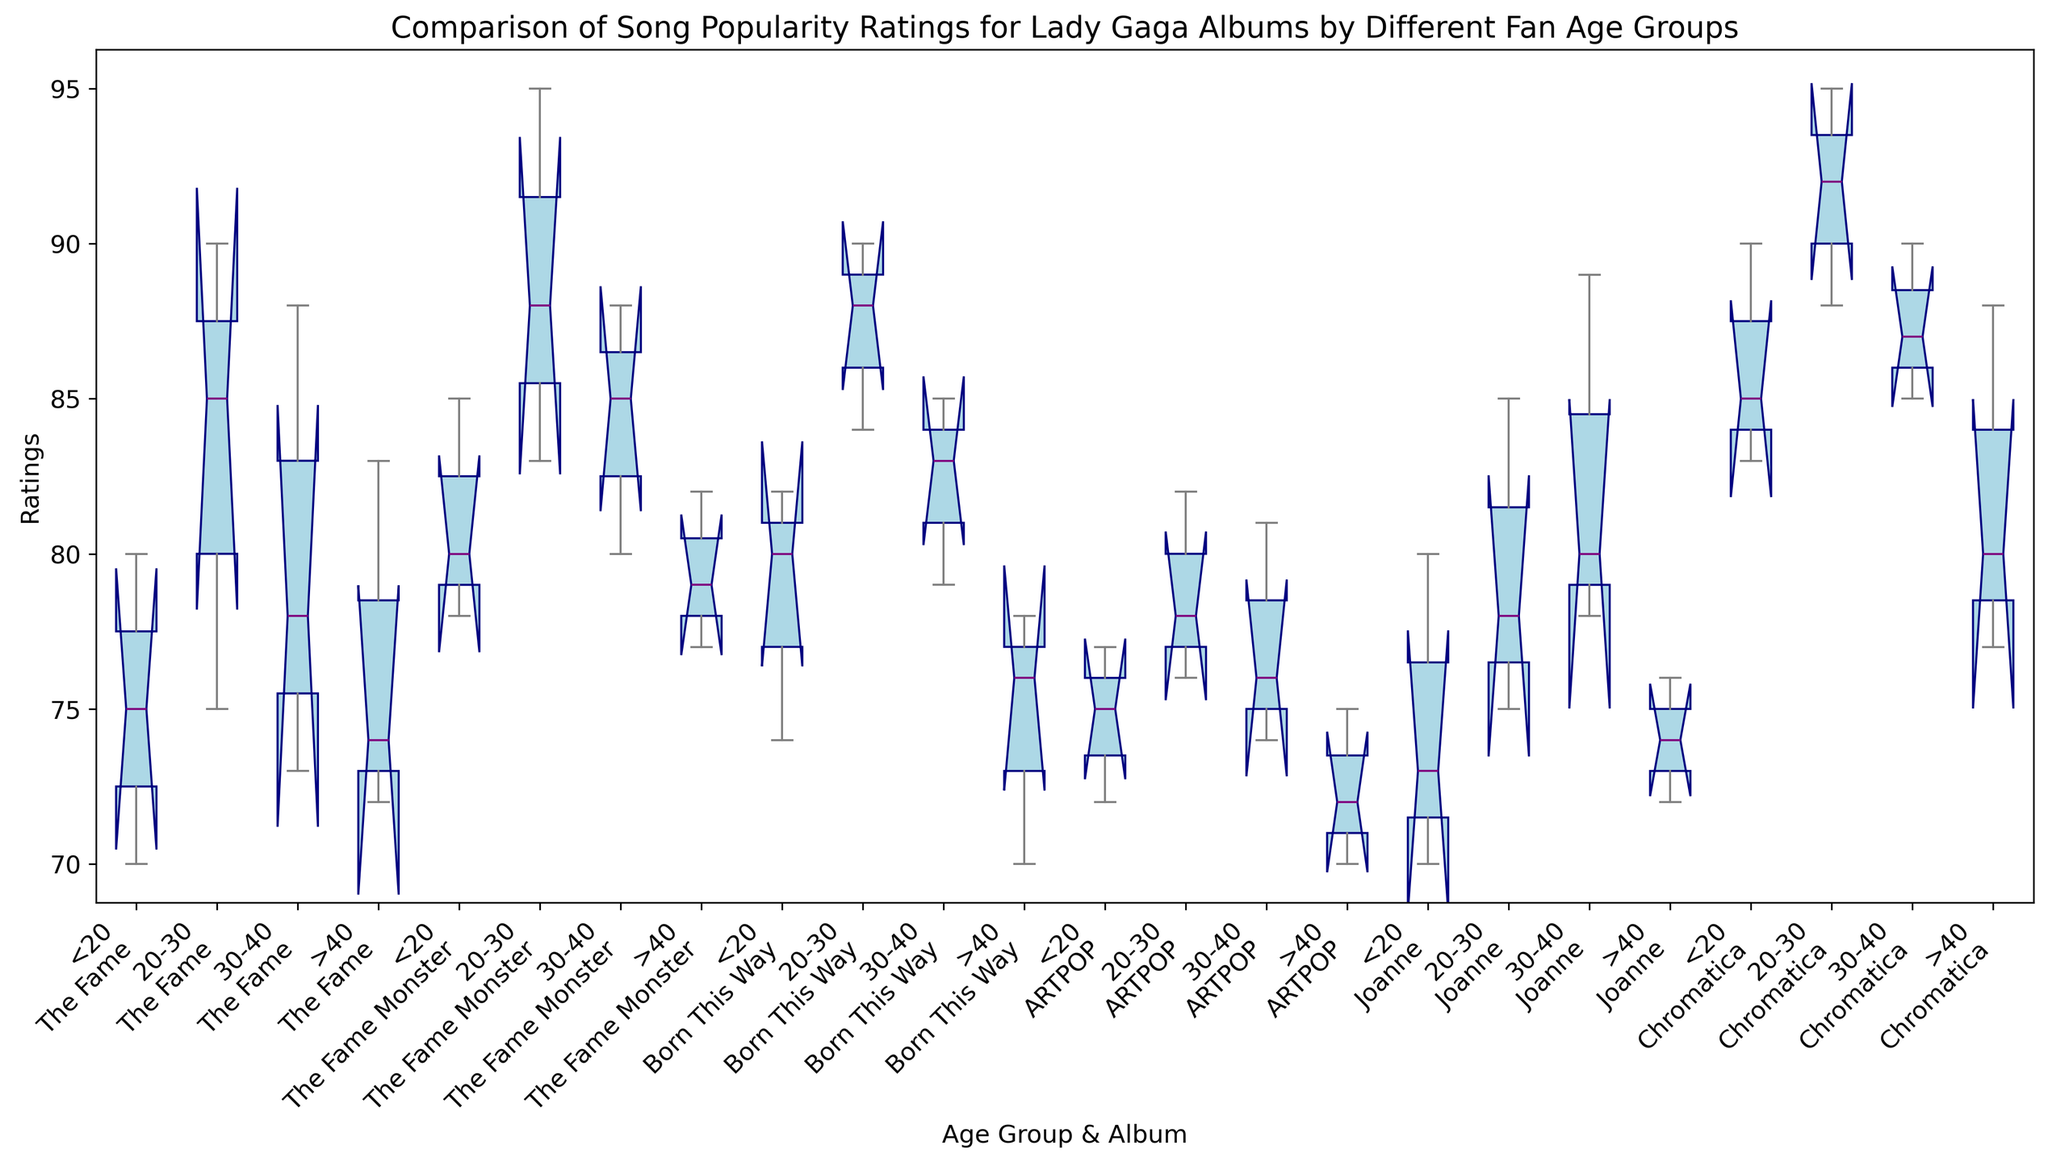What is the median rating for "The Fame" album by fans aged 20-30? Locate the box representing the ratings for "The Fame" and the age group 20-30. The median is the line inside the box, which is at 85.
Answer: 85 Which album has the highest median rating from fans aged 30-40? Identify the boxes corresponding to the age group 30-40 and find the one with the highest median line. "Joanne" has a median at 89.
Answer: Joanne Compare the range of ratings for "Chromatica" between fans aged <20 and >40. Which age group shows a wider range? Observe both ends (whiskers) of the boxes for "Chromatica" in age groups <20 and >40. For <20, it ranges from ~83 to 90, and for >40, it ranges from ~77 to 88. The range (90-83=7) is wider for <20 than for >40 (88-77=11).
Answer: <20 Which album shows the greatest variability in ratings from fans aged 20-30? Identify the boxes corresponding to the age group 20-30 and measure the length of the boxes (interquartile range). "Born This Way" shows greatest variability as its box is the tallest.
Answer: Born This Way Do fans older than 40 give higher ratings to "The Fame" or "The Fame Monster"? Compare the median lines of "The Fame" and "The Fame Monster" for the >40 age group. The median for "The Fame Monster" (82) is higher than "The Fame" (74).
Answer: The Fame Monster Which album received the most consistently high ratings from fans aged less than 20? Check the boxes for the age group <20 and find the one with a higher lower whisker and upper whisker nearby. "Chromatica" shows consistently high ratings from ~83 to 90.
Answer: Chromatica Is the median rating for "ARTPOP" higher among fans aged 20-30 or those aged 30-40? Locate the boxes for "ARTPOP" in age groups 20-30 and 30-40. The median of 20-30 (82) is slightly higher than 30-40 (81).
Answer: 20-30 For "The Fame Monster," in which age group does it have the smallest interquartile range (IQR)? Look at the boxes for each age group within "The Fame Monster" and measure the height of the boxes. The age group <20 has the shortest box, indicating the smallest IQR.
Answer: <20 